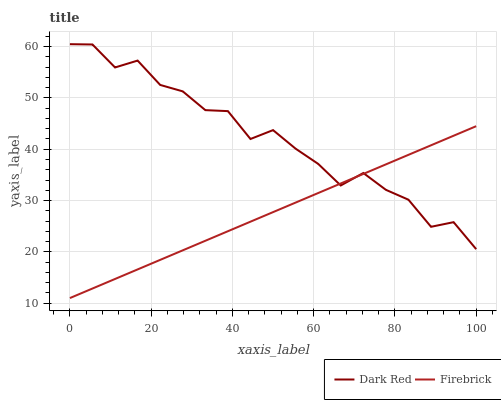Does Firebrick have the minimum area under the curve?
Answer yes or no. Yes. Does Dark Red have the maximum area under the curve?
Answer yes or no. Yes. Does Firebrick have the maximum area under the curve?
Answer yes or no. No. Is Firebrick the smoothest?
Answer yes or no. Yes. Is Dark Red the roughest?
Answer yes or no. Yes. Is Firebrick the roughest?
Answer yes or no. No. Does Firebrick have the lowest value?
Answer yes or no. Yes. Does Dark Red have the highest value?
Answer yes or no. Yes. Does Firebrick have the highest value?
Answer yes or no. No. Does Firebrick intersect Dark Red?
Answer yes or no. Yes. Is Firebrick less than Dark Red?
Answer yes or no. No. Is Firebrick greater than Dark Red?
Answer yes or no. No. 